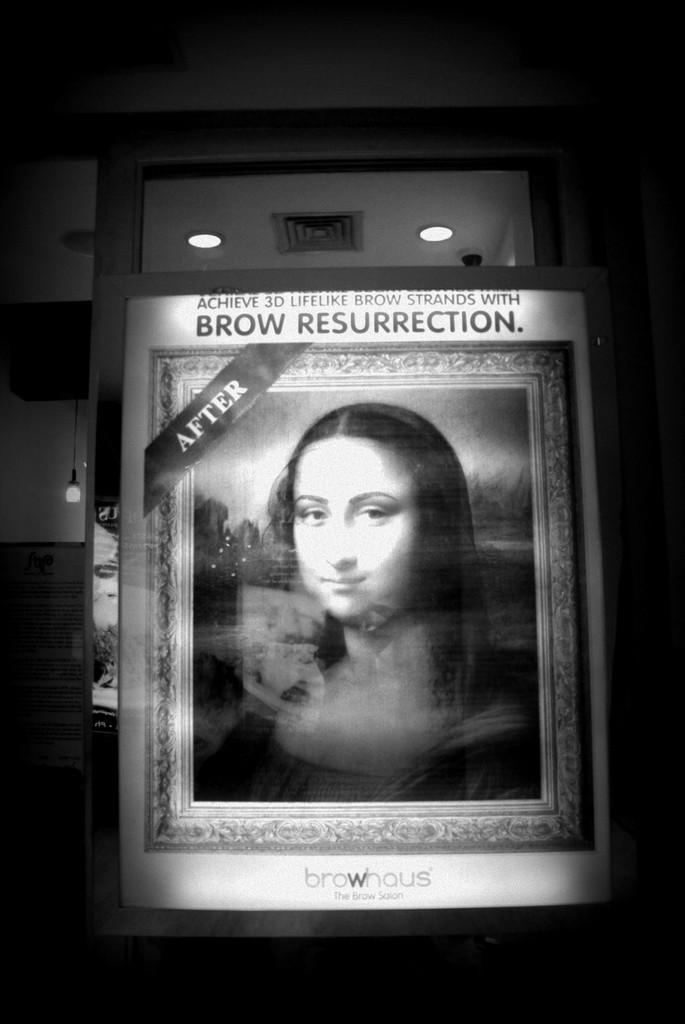How would you summarize this image in a sentence or two? In this Image I can see the board. In the board there is a person I can see something is written in the top of the board. In the back I can see the lights and this is a black and white image. 